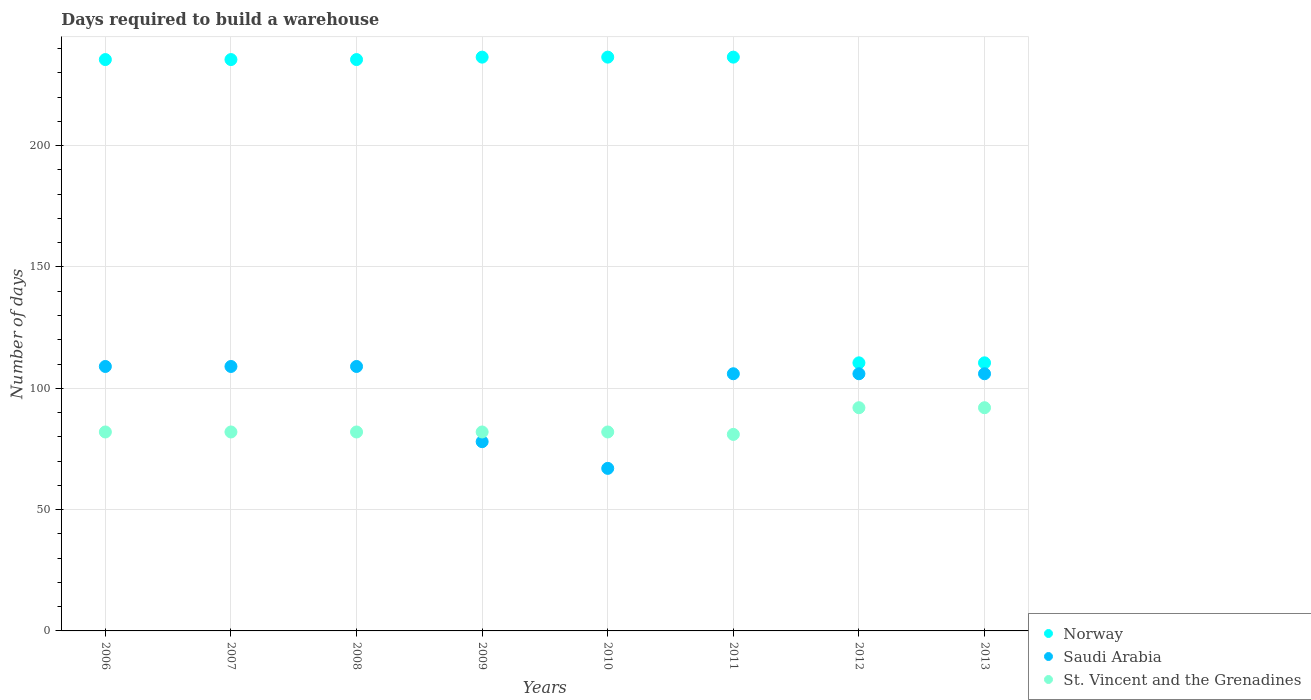How many different coloured dotlines are there?
Give a very brief answer. 3. What is the days required to build a warehouse in in Norway in 2008?
Ensure brevity in your answer.  235.5. Across all years, what is the maximum days required to build a warehouse in in Norway?
Ensure brevity in your answer.  236.5. Across all years, what is the minimum days required to build a warehouse in in Saudi Arabia?
Make the answer very short. 67. What is the total days required to build a warehouse in in Norway in the graph?
Provide a succinct answer. 1637. What is the difference between the days required to build a warehouse in in St. Vincent and the Grenadines in 2006 and that in 2010?
Your answer should be very brief. 0. What is the difference between the days required to build a warehouse in in Saudi Arabia in 2009 and the days required to build a warehouse in in St. Vincent and the Grenadines in 2012?
Provide a succinct answer. -14. What is the average days required to build a warehouse in in St. Vincent and the Grenadines per year?
Ensure brevity in your answer.  84.38. In the year 2007, what is the difference between the days required to build a warehouse in in Norway and days required to build a warehouse in in Saudi Arabia?
Your response must be concise. 126.5. What is the ratio of the days required to build a warehouse in in Norway in 2006 to that in 2010?
Provide a succinct answer. 1. Is the days required to build a warehouse in in Saudi Arabia in 2010 less than that in 2013?
Provide a short and direct response. Yes. Is the difference between the days required to build a warehouse in in Norway in 2008 and 2011 greater than the difference between the days required to build a warehouse in in Saudi Arabia in 2008 and 2011?
Your answer should be very brief. No. What is the difference between the highest and the lowest days required to build a warehouse in in Saudi Arabia?
Offer a very short reply. 42. In how many years, is the days required to build a warehouse in in Norway greater than the average days required to build a warehouse in in Norway taken over all years?
Ensure brevity in your answer.  6. Is the days required to build a warehouse in in Norway strictly greater than the days required to build a warehouse in in Saudi Arabia over the years?
Provide a succinct answer. Yes. Is the days required to build a warehouse in in Saudi Arabia strictly less than the days required to build a warehouse in in Norway over the years?
Your answer should be very brief. Yes. How many dotlines are there?
Your response must be concise. 3. How many years are there in the graph?
Give a very brief answer. 8. Are the values on the major ticks of Y-axis written in scientific E-notation?
Ensure brevity in your answer.  No. Does the graph contain grids?
Provide a succinct answer. Yes. Where does the legend appear in the graph?
Your answer should be very brief. Bottom right. How many legend labels are there?
Provide a short and direct response. 3. What is the title of the graph?
Provide a short and direct response. Days required to build a warehouse. Does "Turks and Caicos Islands" appear as one of the legend labels in the graph?
Your response must be concise. No. What is the label or title of the X-axis?
Your response must be concise. Years. What is the label or title of the Y-axis?
Provide a short and direct response. Number of days. What is the Number of days of Norway in 2006?
Offer a terse response. 235.5. What is the Number of days in Saudi Arabia in 2006?
Your answer should be very brief. 109. What is the Number of days in Norway in 2007?
Your answer should be very brief. 235.5. What is the Number of days in Saudi Arabia in 2007?
Keep it short and to the point. 109. What is the Number of days of Norway in 2008?
Your answer should be very brief. 235.5. What is the Number of days in Saudi Arabia in 2008?
Ensure brevity in your answer.  109. What is the Number of days in St. Vincent and the Grenadines in 2008?
Provide a succinct answer. 82. What is the Number of days in Norway in 2009?
Offer a very short reply. 236.5. What is the Number of days in Saudi Arabia in 2009?
Make the answer very short. 78. What is the Number of days of Norway in 2010?
Give a very brief answer. 236.5. What is the Number of days in St. Vincent and the Grenadines in 2010?
Your answer should be very brief. 82. What is the Number of days of Norway in 2011?
Your answer should be compact. 236.5. What is the Number of days in Saudi Arabia in 2011?
Give a very brief answer. 106. What is the Number of days in St. Vincent and the Grenadines in 2011?
Make the answer very short. 81. What is the Number of days in Norway in 2012?
Your answer should be compact. 110.5. What is the Number of days in Saudi Arabia in 2012?
Provide a succinct answer. 106. What is the Number of days of St. Vincent and the Grenadines in 2012?
Your answer should be compact. 92. What is the Number of days of Norway in 2013?
Your response must be concise. 110.5. What is the Number of days of Saudi Arabia in 2013?
Keep it short and to the point. 106. What is the Number of days in St. Vincent and the Grenadines in 2013?
Your answer should be compact. 92. Across all years, what is the maximum Number of days of Norway?
Provide a short and direct response. 236.5. Across all years, what is the maximum Number of days of Saudi Arabia?
Your answer should be compact. 109. Across all years, what is the maximum Number of days in St. Vincent and the Grenadines?
Keep it short and to the point. 92. Across all years, what is the minimum Number of days in Norway?
Offer a terse response. 110.5. Across all years, what is the minimum Number of days in St. Vincent and the Grenadines?
Provide a succinct answer. 81. What is the total Number of days in Norway in the graph?
Ensure brevity in your answer.  1637. What is the total Number of days in Saudi Arabia in the graph?
Make the answer very short. 790. What is the total Number of days in St. Vincent and the Grenadines in the graph?
Provide a succinct answer. 675. What is the difference between the Number of days in Saudi Arabia in 2006 and that in 2007?
Your answer should be compact. 0. What is the difference between the Number of days in St. Vincent and the Grenadines in 2006 and that in 2007?
Ensure brevity in your answer.  0. What is the difference between the Number of days of Norway in 2006 and that in 2008?
Provide a succinct answer. 0. What is the difference between the Number of days of Saudi Arabia in 2006 and that in 2008?
Offer a very short reply. 0. What is the difference between the Number of days in Norway in 2006 and that in 2010?
Your answer should be very brief. -1. What is the difference between the Number of days in Norway in 2006 and that in 2012?
Your answer should be compact. 125. What is the difference between the Number of days of Saudi Arabia in 2006 and that in 2012?
Provide a succinct answer. 3. What is the difference between the Number of days in Norway in 2006 and that in 2013?
Provide a succinct answer. 125. What is the difference between the Number of days of Saudi Arabia in 2006 and that in 2013?
Your response must be concise. 3. What is the difference between the Number of days of Saudi Arabia in 2007 and that in 2009?
Provide a succinct answer. 31. What is the difference between the Number of days in St. Vincent and the Grenadines in 2007 and that in 2009?
Give a very brief answer. 0. What is the difference between the Number of days of Norway in 2007 and that in 2010?
Ensure brevity in your answer.  -1. What is the difference between the Number of days in Saudi Arabia in 2007 and that in 2010?
Make the answer very short. 42. What is the difference between the Number of days in Norway in 2007 and that in 2011?
Keep it short and to the point. -1. What is the difference between the Number of days in Saudi Arabia in 2007 and that in 2011?
Offer a terse response. 3. What is the difference between the Number of days in St. Vincent and the Grenadines in 2007 and that in 2011?
Your answer should be compact. 1. What is the difference between the Number of days in Norway in 2007 and that in 2012?
Your answer should be compact. 125. What is the difference between the Number of days in St. Vincent and the Grenadines in 2007 and that in 2012?
Give a very brief answer. -10. What is the difference between the Number of days in Norway in 2007 and that in 2013?
Make the answer very short. 125. What is the difference between the Number of days in St. Vincent and the Grenadines in 2007 and that in 2013?
Provide a short and direct response. -10. What is the difference between the Number of days of Saudi Arabia in 2008 and that in 2009?
Your answer should be compact. 31. What is the difference between the Number of days of St. Vincent and the Grenadines in 2008 and that in 2009?
Give a very brief answer. 0. What is the difference between the Number of days in Saudi Arabia in 2008 and that in 2010?
Your answer should be very brief. 42. What is the difference between the Number of days of St. Vincent and the Grenadines in 2008 and that in 2010?
Your answer should be compact. 0. What is the difference between the Number of days in Saudi Arabia in 2008 and that in 2011?
Offer a very short reply. 3. What is the difference between the Number of days of Norway in 2008 and that in 2012?
Your answer should be very brief. 125. What is the difference between the Number of days of St. Vincent and the Grenadines in 2008 and that in 2012?
Your response must be concise. -10. What is the difference between the Number of days of Norway in 2008 and that in 2013?
Provide a short and direct response. 125. What is the difference between the Number of days in St. Vincent and the Grenadines in 2008 and that in 2013?
Make the answer very short. -10. What is the difference between the Number of days of Norway in 2009 and that in 2010?
Provide a succinct answer. 0. What is the difference between the Number of days in St. Vincent and the Grenadines in 2009 and that in 2010?
Give a very brief answer. 0. What is the difference between the Number of days in Norway in 2009 and that in 2011?
Provide a succinct answer. 0. What is the difference between the Number of days in St. Vincent and the Grenadines in 2009 and that in 2011?
Provide a short and direct response. 1. What is the difference between the Number of days of Norway in 2009 and that in 2012?
Provide a short and direct response. 126. What is the difference between the Number of days in Saudi Arabia in 2009 and that in 2012?
Make the answer very short. -28. What is the difference between the Number of days of St. Vincent and the Grenadines in 2009 and that in 2012?
Keep it short and to the point. -10. What is the difference between the Number of days in Norway in 2009 and that in 2013?
Your response must be concise. 126. What is the difference between the Number of days of St. Vincent and the Grenadines in 2009 and that in 2013?
Your answer should be very brief. -10. What is the difference between the Number of days in Norway in 2010 and that in 2011?
Ensure brevity in your answer.  0. What is the difference between the Number of days of Saudi Arabia in 2010 and that in 2011?
Ensure brevity in your answer.  -39. What is the difference between the Number of days of Norway in 2010 and that in 2012?
Your response must be concise. 126. What is the difference between the Number of days of Saudi Arabia in 2010 and that in 2012?
Ensure brevity in your answer.  -39. What is the difference between the Number of days of St. Vincent and the Grenadines in 2010 and that in 2012?
Offer a terse response. -10. What is the difference between the Number of days of Norway in 2010 and that in 2013?
Make the answer very short. 126. What is the difference between the Number of days of Saudi Arabia in 2010 and that in 2013?
Your response must be concise. -39. What is the difference between the Number of days of Norway in 2011 and that in 2012?
Your answer should be very brief. 126. What is the difference between the Number of days of Norway in 2011 and that in 2013?
Your response must be concise. 126. What is the difference between the Number of days of Saudi Arabia in 2011 and that in 2013?
Ensure brevity in your answer.  0. What is the difference between the Number of days in Saudi Arabia in 2012 and that in 2013?
Keep it short and to the point. 0. What is the difference between the Number of days of St. Vincent and the Grenadines in 2012 and that in 2013?
Offer a terse response. 0. What is the difference between the Number of days in Norway in 2006 and the Number of days in Saudi Arabia in 2007?
Your answer should be very brief. 126.5. What is the difference between the Number of days in Norway in 2006 and the Number of days in St. Vincent and the Grenadines in 2007?
Offer a very short reply. 153.5. What is the difference between the Number of days of Norway in 2006 and the Number of days of Saudi Arabia in 2008?
Keep it short and to the point. 126.5. What is the difference between the Number of days in Norway in 2006 and the Number of days in St. Vincent and the Grenadines in 2008?
Keep it short and to the point. 153.5. What is the difference between the Number of days in Saudi Arabia in 2006 and the Number of days in St. Vincent and the Grenadines in 2008?
Provide a succinct answer. 27. What is the difference between the Number of days of Norway in 2006 and the Number of days of Saudi Arabia in 2009?
Your answer should be very brief. 157.5. What is the difference between the Number of days of Norway in 2006 and the Number of days of St. Vincent and the Grenadines in 2009?
Provide a short and direct response. 153.5. What is the difference between the Number of days of Saudi Arabia in 2006 and the Number of days of St. Vincent and the Grenadines in 2009?
Provide a succinct answer. 27. What is the difference between the Number of days in Norway in 2006 and the Number of days in Saudi Arabia in 2010?
Give a very brief answer. 168.5. What is the difference between the Number of days in Norway in 2006 and the Number of days in St. Vincent and the Grenadines in 2010?
Keep it short and to the point. 153.5. What is the difference between the Number of days in Norway in 2006 and the Number of days in Saudi Arabia in 2011?
Offer a terse response. 129.5. What is the difference between the Number of days of Norway in 2006 and the Number of days of St. Vincent and the Grenadines in 2011?
Provide a succinct answer. 154.5. What is the difference between the Number of days of Saudi Arabia in 2006 and the Number of days of St. Vincent and the Grenadines in 2011?
Make the answer very short. 28. What is the difference between the Number of days of Norway in 2006 and the Number of days of Saudi Arabia in 2012?
Give a very brief answer. 129.5. What is the difference between the Number of days in Norway in 2006 and the Number of days in St. Vincent and the Grenadines in 2012?
Offer a terse response. 143.5. What is the difference between the Number of days of Norway in 2006 and the Number of days of Saudi Arabia in 2013?
Provide a succinct answer. 129.5. What is the difference between the Number of days of Norway in 2006 and the Number of days of St. Vincent and the Grenadines in 2013?
Your response must be concise. 143.5. What is the difference between the Number of days in Saudi Arabia in 2006 and the Number of days in St. Vincent and the Grenadines in 2013?
Keep it short and to the point. 17. What is the difference between the Number of days in Norway in 2007 and the Number of days in Saudi Arabia in 2008?
Keep it short and to the point. 126.5. What is the difference between the Number of days in Norway in 2007 and the Number of days in St. Vincent and the Grenadines in 2008?
Offer a very short reply. 153.5. What is the difference between the Number of days of Norway in 2007 and the Number of days of Saudi Arabia in 2009?
Give a very brief answer. 157.5. What is the difference between the Number of days of Norway in 2007 and the Number of days of St. Vincent and the Grenadines in 2009?
Give a very brief answer. 153.5. What is the difference between the Number of days in Norway in 2007 and the Number of days in Saudi Arabia in 2010?
Provide a succinct answer. 168.5. What is the difference between the Number of days in Norway in 2007 and the Number of days in St. Vincent and the Grenadines in 2010?
Keep it short and to the point. 153.5. What is the difference between the Number of days of Norway in 2007 and the Number of days of Saudi Arabia in 2011?
Your answer should be very brief. 129.5. What is the difference between the Number of days of Norway in 2007 and the Number of days of St. Vincent and the Grenadines in 2011?
Your response must be concise. 154.5. What is the difference between the Number of days in Norway in 2007 and the Number of days in Saudi Arabia in 2012?
Give a very brief answer. 129.5. What is the difference between the Number of days of Norway in 2007 and the Number of days of St. Vincent and the Grenadines in 2012?
Your answer should be compact. 143.5. What is the difference between the Number of days in Saudi Arabia in 2007 and the Number of days in St. Vincent and the Grenadines in 2012?
Your answer should be very brief. 17. What is the difference between the Number of days of Norway in 2007 and the Number of days of Saudi Arabia in 2013?
Your response must be concise. 129.5. What is the difference between the Number of days of Norway in 2007 and the Number of days of St. Vincent and the Grenadines in 2013?
Keep it short and to the point. 143.5. What is the difference between the Number of days in Saudi Arabia in 2007 and the Number of days in St. Vincent and the Grenadines in 2013?
Provide a short and direct response. 17. What is the difference between the Number of days in Norway in 2008 and the Number of days in Saudi Arabia in 2009?
Provide a succinct answer. 157.5. What is the difference between the Number of days of Norway in 2008 and the Number of days of St. Vincent and the Grenadines in 2009?
Provide a succinct answer. 153.5. What is the difference between the Number of days of Saudi Arabia in 2008 and the Number of days of St. Vincent and the Grenadines in 2009?
Your answer should be very brief. 27. What is the difference between the Number of days of Norway in 2008 and the Number of days of Saudi Arabia in 2010?
Your answer should be compact. 168.5. What is the difference between the Number of days in Norway in 2008 and the Number of days in St. Vincent and the Grenadines in 2010?
Your answer should be compact. 153.5. What is the difference between the Number of days in Norway in 2008 and the Number of days in Saudi Arabia in 2011?
Offer a terse response. 129.5. What is the difference between the Number of days in Norway in 2008 and the Number of days in St. Vincent and the Grenadines in 2011?
Offer a very short reply. 154.5. What is the difference between the Number of days of Norway in 2008 and the Number of days of Saudi Arabia in 2012?
Ensure brevity in your answer.  129.5. What is the difference between the Number of days in Norway in 2008 and the Number of days in St. Vincent and the Grenadines in 2012?
Your answer should be compact. 143.5. What is the difference between the Number of days in Saudi Arabia in 2008 and the Number of days in St. Vincent and the Grenadines in 2012?
Give a very brief answer. 17. What is the difference between the Number of days in Norway in 2008 and the Number of days in Saudi Arabia in 2013?
Offer a very short reply. 129.5. What is the difference between the Number of days in Norway in 2008 and the Number of days in St. Vincent and the Grenadines in 2013?
Your response must be concise. 143.5. What is the difference between the Number of days in Norway in 2009 and the Number of days in Saudi Arabia in 2010?
Provide a short and direct response. 169.5. What is the difference between the Number of days in Norway in 2009 and the Number of days in St. Vincent and the Grenadines in 2010?
Your answer should be compact. 154.5. What is the difference between the Number of days of Saudi Arabia in 2009 and the Number of days of St. Vincent and the Grenadines in 2010?
Your answer should be very brief. -4. What is the difference between the Number of days of Norway in 2009 and the Number of days of Saudi Arabia in 2011?
Keep it short and to the point. 130.5. What is the difference between the Number of days of Norway in 2009 and the Number of days of St. Vincent and the Grenadines in 2011?
Your answer should be compact. 155.5. What is the difference between the Number of days of Norway in 2009 and the Number of days of Saudi Arabia in 2012?
Give a very brief answer. 130.5. What is the difference between the Number of days of Norway in 2009 and the Number of days of St. Vincent and the Grenadines in 2012?
Provide a succinct answer. 144.5. What is the difference between the Number of days of Saudi Arabia in 2009 and the Number of days of St. Vincent and the Grenadines in 2012?
Offer a very short reply. -14. What is the difference between the Number of days of Norway in 2009 and the Number of days of Saudi Arabia in 2013?
Give a very brief answer. 130.5. What is the difference between the Number of days in Norway in 2009 and the Number of days in St. Vincent and the Grenadines in 2013?
Provide a short and direct response. 144.5. What is the difference between the Number of days of Norway in 2010 and the Number of days of Saudi Arabia in 2011?
Give a very brief answer. 130.5. What is the difference between the Number of days in Norway in 2010 and the Number of days in St. Vincent and the Grenadines in 2011?
Offer a very short reply. 155.5. What is the difference between the Number of days in Saudi Arabia in 2010 and the Number of days in St. Vincent and the Grenadines in 2011?
Provide a succinct answer. -14. What is the difference between the Number of days in Norway in 2010 and the Number of days in Saudi Arabia in 2012?
Provide a short and direct response. 130.5. What is the difference between the Number of days in Norway in 2010 and the Number of days in St. Vincent and the Grenadines in 2012?
Offer a very short reply. 144.5. What is the difference between the Number of days in Norway in 2010 and the Number of days in Saudi Arabia in 2013?
Ensure brevity in your answer.  130.5. What is the difference between the Number of days of Norway in 2010 and the Number of days of St. Vincent and the Grenadines in 2013?
Make the answer very short. 144.5. What is the difference between the Number of days in Saudi Arabia in 2010 and the Number of days in St. Vincent and the Grenadines in 2013?
Provide a short and direct response. -25. What is the difference between the Number of days of Norway in 2011 and the Number of days of Saudi Arabia in 2012?
Provide a short and direct response. 130.5. What is the difference between the Number of days in Norway in 2011 and the Number of days in St. Vincent and the Grenadines in 2012?
Keep it short and to the point. 144.5. What is the difference between the Number of days in Norway in 2011 and the Number of days in Saudi Arabia in 2013?
Keep it short and to the point. 130.5. What is the difference between the Number of days of Norway in 2011 and the Number of days of St. Vincent and the Grenadines in 2013?
Keep it short and to the point. 144.5. What is the difference between the Number of days in Norway in 2012 and the Number of days in Saudi Arabia in 2013?
Offer a very short reply. 4.5. What is the difference between the Number of days in Saudi Arabia in 2012 and the Number of days in St. Vincent and the Grenadines in 2013?
Offer a terse response. 14. What is the average Number of days of Norway per year?
Provide a succinct answer. 204.62. What is the average Number of days of Saudi Arabia per year?
Offer a terse response. 98.75. What is the average Number of days of St. Vincent and the Grenadines per year?
Provide a short and direct response. 84.38. In the year 2006, what is the difference between the Number of days of Norway and Number of days of Saudi Arabia?
Make the answer very short. 126.5. In the year 2006, what is the difference between the Number of days in Norway and Number of days in St. Vincent and the Grenadines?
Provide a short and direct response. 153.5. In the year 2007, what is the difference between the Number of days of Norway and Number of days of Saudi Arabia?
Your response must be concise. 126.5. In the year 2007, what is the difference between the Number of days of Norway and Number of days of St. Vincent and the Grenadines?
Offer a very short reply. 153.5. In the year 2007, what is the difference between the Number of days in Saudi Arabia and Number of days in St. Vincent and the Grenadines?
Offer a very short reply. 27. In the year 2008, what is the difference between the Number of days in Norway and Number of days in Saudi Arabia?
Your answer should be compact. 126.5. In the year 2008, what is the difference between the Number of days of Norway and Number of days of St. Vincent and the Grenadines?
Offer a very short reply. 153.5. In the year 2009, what is the difference between the Number of days of Norway and Number of days of Saudi Arabia?
Keep it short and to the point. 158.5. In the year 2009, what is the difference between the Number of days in Norway and Number of days in St. Vincent and the Grenadines?
Give a very brief answer. 154.5. In the year 2010, what is the difference between the Number of days of Norway and Number of days of Saudi Arabia?
Ensure brevity in your answer.  169.5. In the year 2010, what is the difference between the Number of days of Norway and Number of days of St. Vincent and the Grenadines?
Ensure brevity in your answer.  154.5. In the year 2010, what is the difference between the Number of days in Saudi Arabia and Number of days in St. Vincent and the Grenadines?
Provide a succinct answer. -15. In the year 2011, what is the difference between the Number of days of Norway and Number of days of Saudi Arabia?
Make the answer very short. 130.5. In the year 2011, what is the difference between the Number of days of Norway and Number of days of St. Vincent and the Grenadines?
Keep it short and to the point. 155.5. In the year 2012, what is the difference between the Number of days of Norway and Number of days of Saudi Arabia?
Provide a short and direct response. 4.5. What is the ratio of the Number of days of Norway in 2006 to that in 2007?
Provide a short and direct response. 1. What is the ratio of the Number of days in St. Vincent and the Grenadines in 2006 to that in 2008?
Keep it short and to the point. 1. What is the ratio of the Number of days in Saudi Arabia in 2006 to that in 2009?
Offer a very short reply. 1.4. What is the ratio of the Number of days in St. Vincent and the Grenadines in 2006 to that in 2009?
Your response must be concise. 1. What is the ratio of the Number of days in Norway in 2006 to that in 2010?
Your answer should be very brief. 1. What is the ratio of the Number of days in Saudi Arabia in 2006 to that in 2010?
Ensure brevity in your answer.  1.63. What is the ratio of the Number of days in Norway in 2006 to that in 2011?
Provide a short and direct response. 1. What is the ratio of the Number of days of Saudi Arabia in 2006 to that in 2011?
Ensure brevity in your answer.  1.03. What is the ratio of the Number of days in St. Vincent and the Grenadines in 2006 to that in 2011?
Ensure brevity in your answer.  1.01. What is the ratio of the Number of days in Norway in 2006 to that in 2012?
Your answer should be very brief. 2.13. What is the ratio of the Number of days of Saudi Arabia in 2006 to that in 2012?
Your response must be concise. 1.03. What is the ratio of the Number of days in St. Vincent and the Grenadines in 2006 to that in 2012?
Your answer should be compact. 0.89. What is the ratio of the Number of days of Norway in 2006 to that in 2013?
Your answer should be compact. 2.13. What is the ratio of the Number of days in Saudi Arabia in 2006 to that in 2013?
Give a very brief answer. 1.03. What is the ratio of the Number of days of St. Vincent and the Grenadines in 2006 to that in 2013?
Your answer should be compact. 0.89. What is the ratio of the Number of days of Saudi Arabia in 2007 to that in 2009?
Provide a succinct answer. 1.4. What is the ratio of the Number of days in St. Vincent and the Grenadines in 2007 to that in 2009?
Your answer should be very brief. 1. What is the ratio of the Number of days in Norway in 2007 to that in 2010?
Your response must be concise. 1. What is the ratio of the Number of days in Saudi Arabia in 2007 to that in 2010?
Your answer should be very brief. 1.63. What is the ratio of the Number of days of Norway in 2007 to that in 2011?
Keep it short and to the point. 1. What is the ratio of the Number of days of Saudi Arabia in 2007 to that in 2011?
Ensure brevity in your answer.  1.03. What is the ratio of the Number of days of St. Vincent and the Grenadines in 2007 to that in 2011?
Your answer should be very brief. 1.01. What is the ratio of the Number of days of Norway in 2007 to that in 2012?
Offer a terse response. 2.13. What is the ratio of the Number of days in Saudi Arabia in 2007 to that in 2012?
Provide a succinct answer. 1.03. What is the ratio of the Number of days of St. Vincent and the Grenadines in 2007 to that in 2012?
Keep it short and to the point. 0.89. What is the ratio of the Number of days in Norway in 2007 to that in 2013?
Make the answer very short. 2.13. What is the ratio of the Number of days in Saudi Arabia in 2007 to that in 2013?
Ensure brevity in your answer.  1.03. What is the ratio of the Number of days of St. Vincent and the Grenadines in 2007 to that in 2013?
Offer a terse response. 0.89. What is the ratio of the Number of days of Saudi Arabia in 2008 to that in 2009?
Provide a succinct answer. 1.4. What is the ratio of the Number of days in Saudi Arabia in 2008 to that in 2010?
Give a very brief answer. 1.63. What is the ratio of the Number of days of St. Vincent and the Grenadines in 2008 to that in 2010?
Give a very brief answer. 1. What is the ratio of the Number of days in Saudi Arabia in 2008 to that in 2011?
Offer a very short reply. 1.03. What is the ratio of the Number of days in St. Vincent and the Grenadines in 2008 to that in 2011?
Offer a very short reply. 1.01. What is the ratio of the Number of days in Norway in 2008 to that in 2012?
Ensure brevity in your answer.  2.13. What is the ratio of the Number of days of Saudi Arabia in 2008 to that in 2012?
Make the answer very short. 1.03. What is the ratio of the Number of days of St. Vincent and the Grenadines in 2008 to that in 2012?
Offer a terse response. 0.89. What is the ratio of the Number of days in Norway in 2008 to that in 2013?
Keep it short and to the point. 2.13. What is the ratio of the Number of days of Saudi Arabia in 2008 to that in 2013?
Provide a succinct answer. 1.03. What is the ratio of the Number of days in St. Vincent and the Grenadines in 2008 to that in 2013?
Your answer should be very brief. 0.89. What is the ratio of the Number of days in Norway in 2009 to that in 2010?
Make the answer very short. 1. What is the ratio of the Number of days in Saudi Arabia in 2009 to that in 2010?
Provide a succinct answer. 1.16. What is the ratio of the Number of days in Saudi Arabia in 2009 to that in 2011?
Provide a short and direct response. 0.74. What is the ratio of the Number of days in St. Vincent and the Grenadines in 2009 to that in 2011?
Provide a short and direct response. 1.01. What is the ratio of the Number of days of Norway in 2009 to that in 2012?
Provide a short and direct response. 2.14. What is the ratio of the Number of days in Saudi Arabia in 2009 to that in 2012?
Give a very brief answer. 0.74. What is the ratio of the Number of days of St. Vincent and the Grenadines in 2009 to that in 2012?
Your answer should be very brief. 0.89. What is the ratio of the Number of days of Norway in 2009 to that in 2013?
Your answer should be compact. 2.14. What is the ratio of the Number of days in Saudi Arabia in 2009 to that in 2013?
Provide a succinct answer. 0.74. What is the ratio of the Number of days in St. Vincent and the Grenadines in 2009 to that in 2013?
Your answer should be very brief. 0.89. What is the ratio of the Number of days of Norway in 2010 to that in 2011?
Your answer should be very brief. 1. What is the ratio of the Number of days in Saudi Arabia in 2010 to that in 2011?
Keep it short and to the point. 0.63. What is the ratio of the Number of days in St. Vincent and the Grenadines in 2010 to that in 2011?
Your response must be concise. 1.01. What is the ratio of the Number of days in Norway in 2010 to that in 2012?
Your response must be concise. 2.14. What is the ratio of the Number of days in Saudi Arabia in 2010 to that in 2012?
Offer a very short reply. 0.63. What is the ratio of the Number of days in St. Vincent and the Grenadines in 2010 to that in 2012?
Keep it short and to the point. 0.89. What is the ratio of the Number of days in Norway in 2010 to that in 2013?
Offer a terse response. 2.14. What is the ratio of the Number of days in Saudi Arabia in 2010 to that in 2013?
Provide a succinct answer. 0.63. What is the ratio of the Number of days in St. Vincent and the Grenadines in 2010 to that in 2013?
Your response must be concise. 0.89. What is the ratio of the Number of days of Norway in 2011 to that in 2012?
Provide a succinct answer. 2.14. What is the ratio of the Number of days in St. Vincent and the Grenadines in 2011 to that in 2012?
Ensure brevity in your answer.  0.88. What is the ratio of the Number of days of Norway in 2011 to that in 2013?
Provide a succinct answer. 2.14. What is the ratio of the Number of days of St. Vincent and the Grenadines in 2011 to that in 2013?
Your answer should be compact. 0.88. What is the difference between the highest and the second highest Number of days in Norway?
Provide a succinct answer. 0. What is the difference between the highest and the second highest Number of days of St. Vincent and the Grenadines?
Your response must be concise. 0. What is the difference between the highest and the lowest Number of days in Norway?
Give a very brief answer. 126. What is the difference between the highest and the lowest Number of days of St. Vincent and the Grenadines?
Provide a short and direct response. 11. 